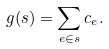<formula> <loc_0><loc_0><loc_500><loc_500>g ( s ) = \sum _ { e \in s } c _ { e } .</formula> 